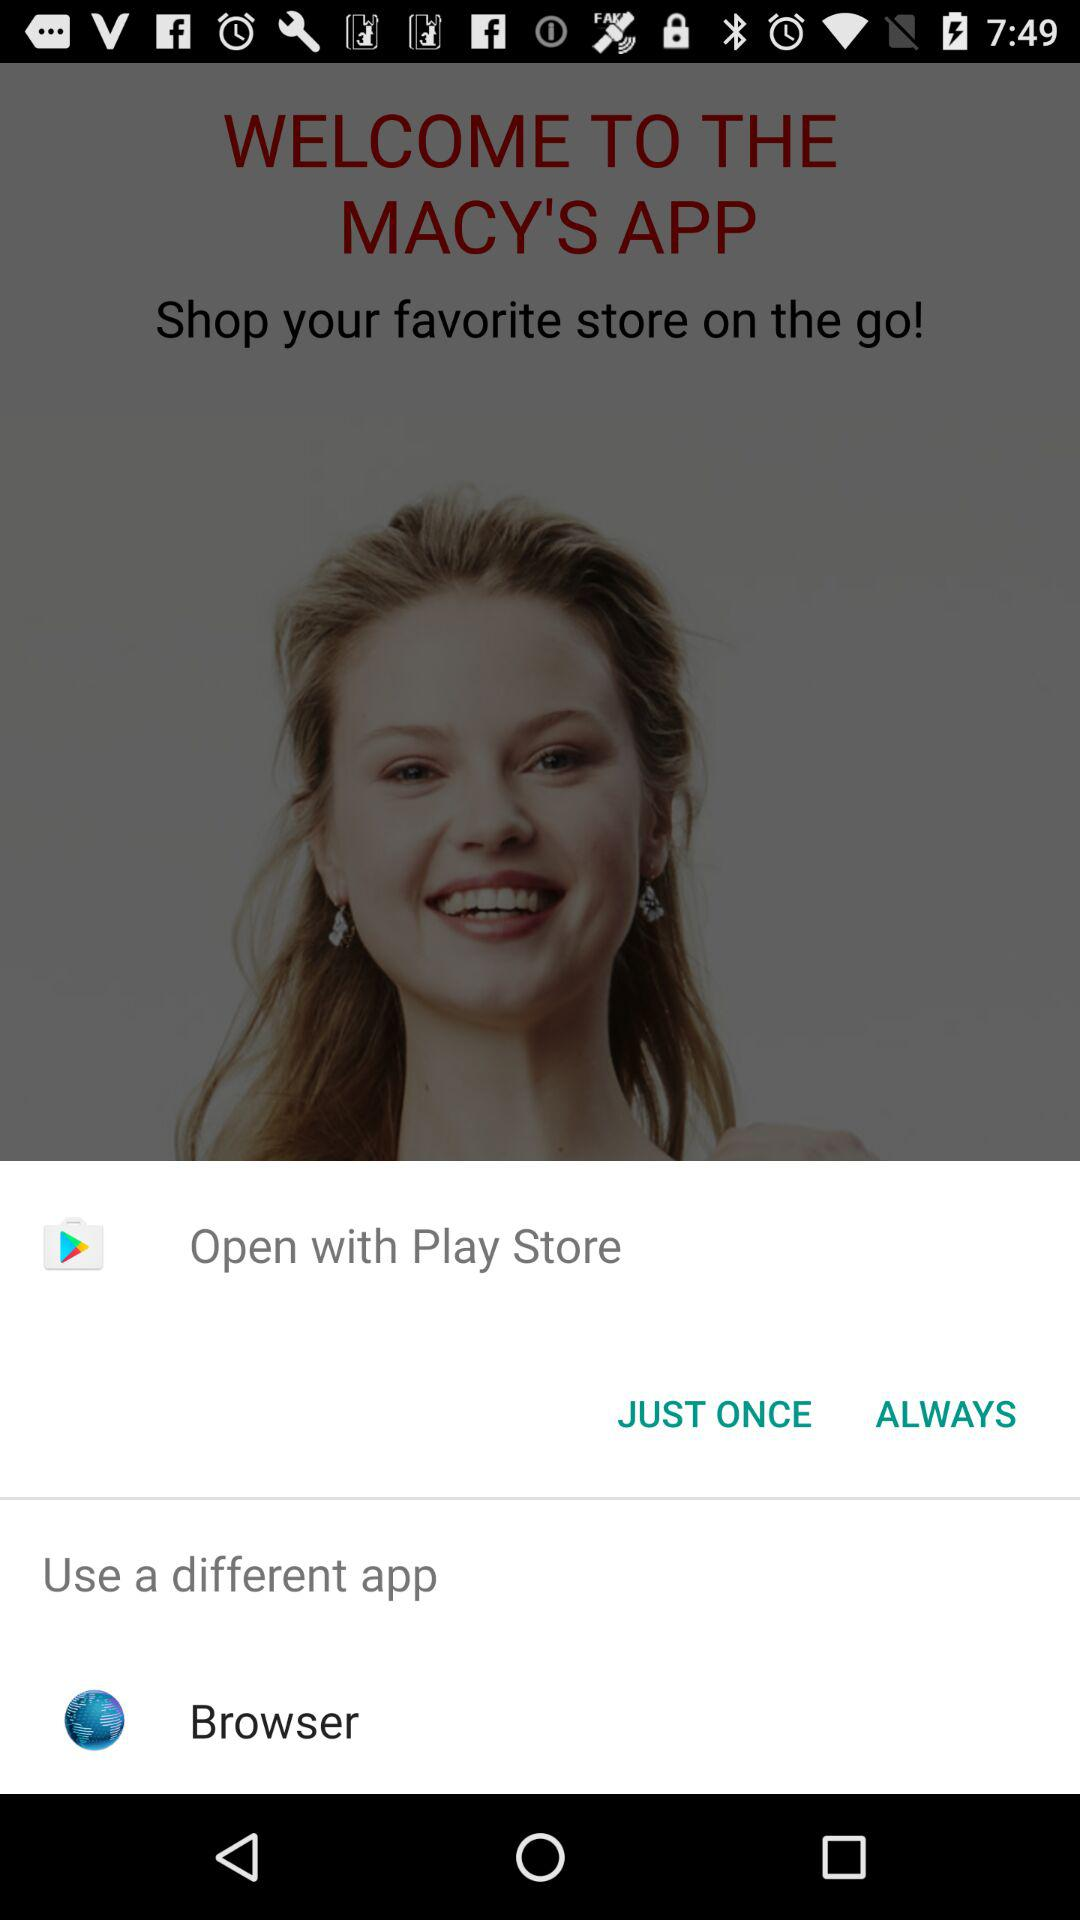What applications can be used to open? The applications are "Play Store" and "Browser". 